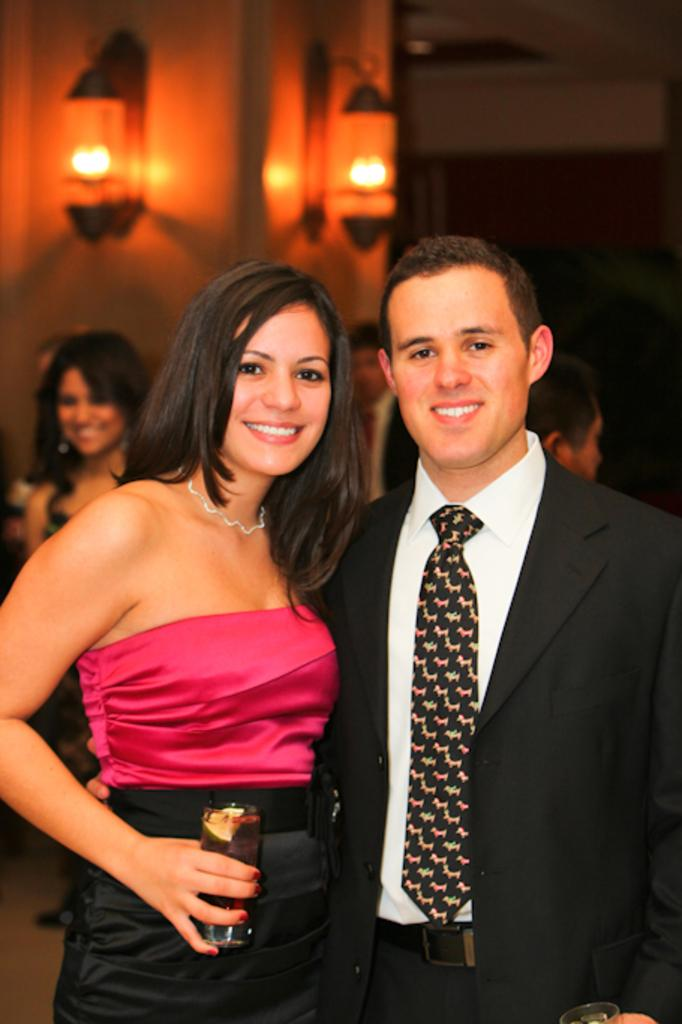How many people are visible in the image? There are two persons standing and smiling in the image. What is the person on the left holding in the image? The person on the left is holding a glass in the image. Can you describe the background of the image? There is a group of people and lights visible in the background of the image. What type of industry can be seen in the background of the image? There is no industry visible in the background of the image; it features a group of people and lights. Can you tell me what is written in the notebook on the table in the image? There is no notebook present in the image. 